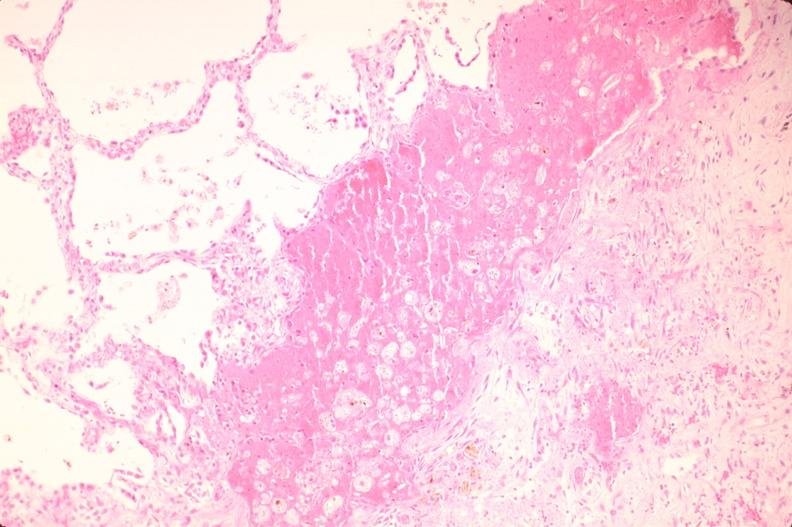what is present?
Answer the question using a single word or phrase. Respiratory 